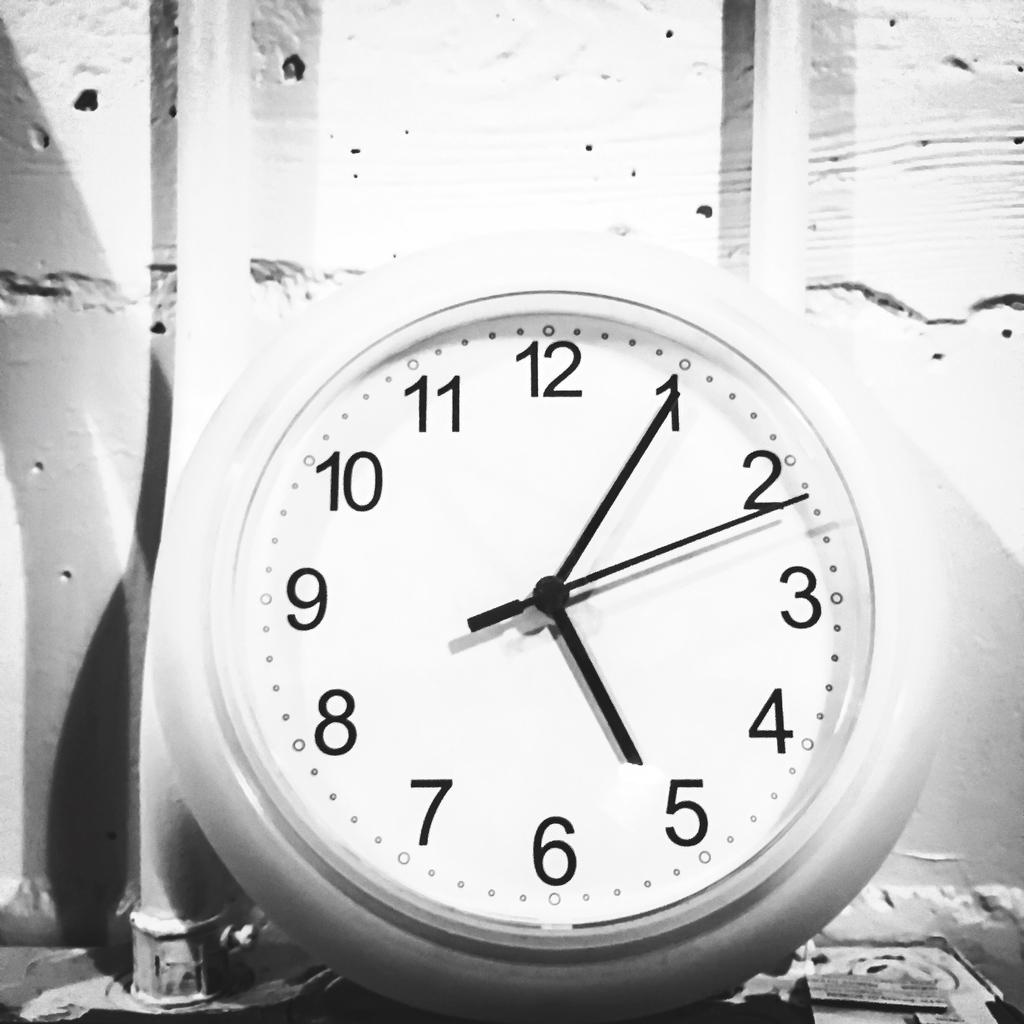<image>
Describe the image concisely. A clock displays the time of 5:05, with the hour hand pointing to the 5 and the minute hand pointing to the 1. 